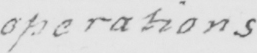Can you tell me what this handwritten text says? operations 